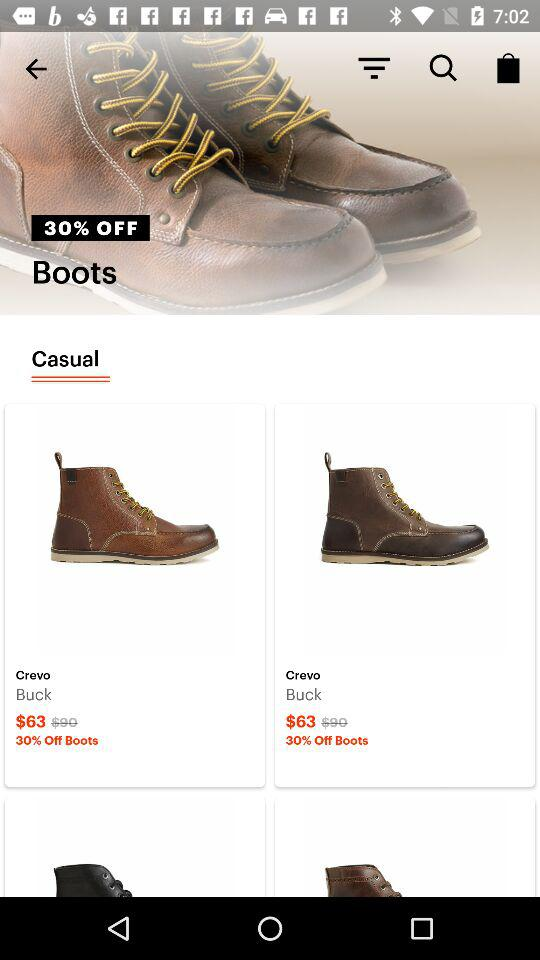What is the price of "Crevo" after the discount? The price of "Crevo" after the discount is $63. 